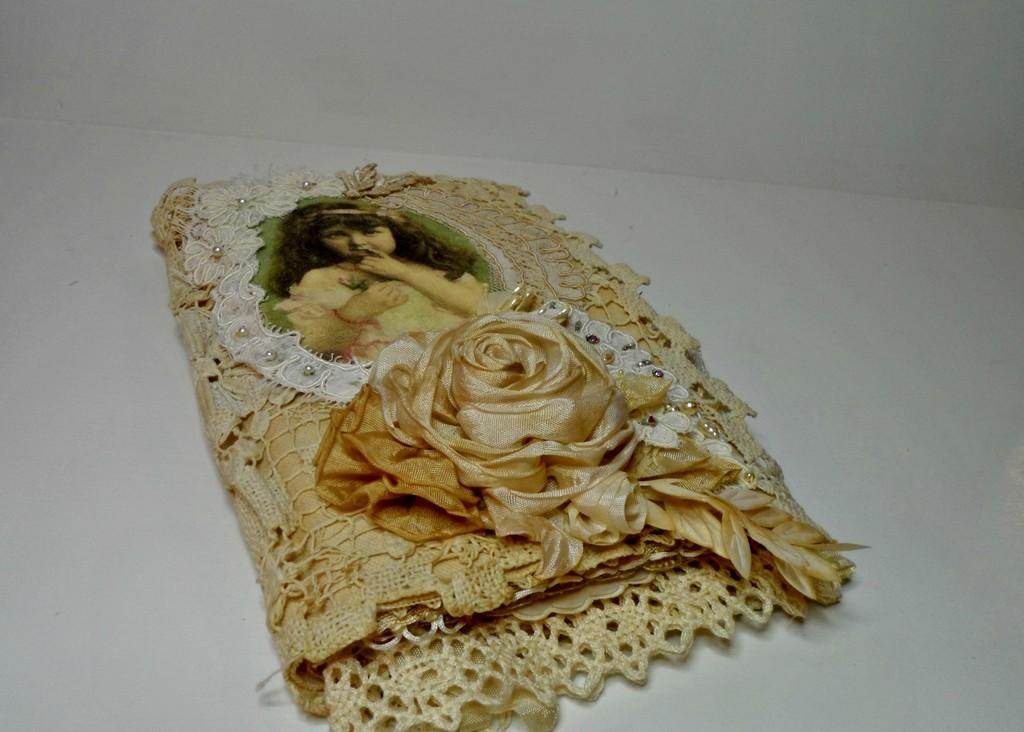What type of fabric is visible in the image? There is a lace present in the image. What is depicted on the lace? There is a picture of a girl on the lace. What type of cable can be seen connecting the girl to the lace in the image? There is no cable present in the image; it only features a lace with a picture of a girl. 